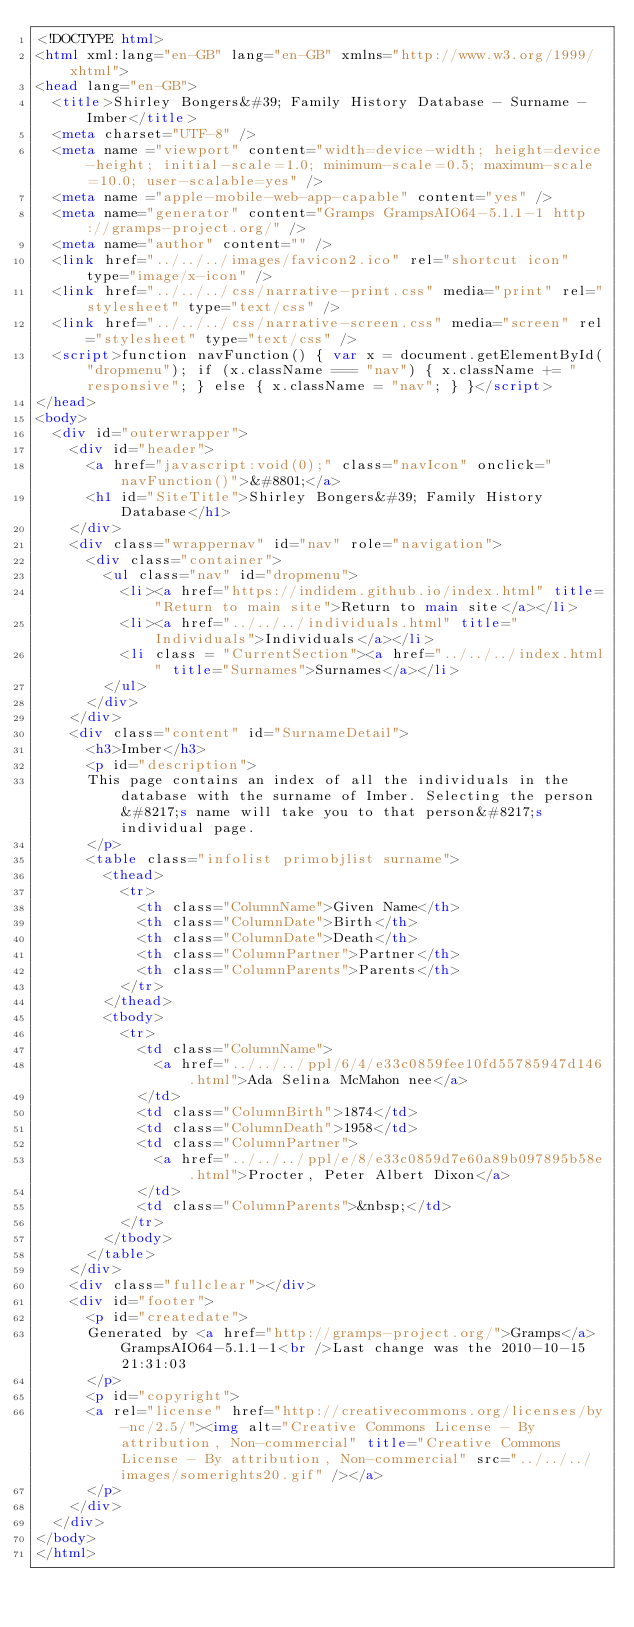Convert code to text. <code><loc_0><loc_0><loc_500><loc_500><_HTML_><!DOCTYPE html>
<html xml:lang="en-GB" lang="en-GB" xmlns="http://www.w3.org/1999/xhtml">
<head lang="en-GB">
	<title>Shirley Bongers&#39; Family History Database - Surname - Imber</title>
	<meta charset="UTF-8" />
	<meta name ="viewport" content="width=device-width; height=device-height; initial-scale=1.0; minimum-scale=0.5; maximum-scale=10.0; user-scalable=yes" />
	<meta name ="apple-mobile-web-app-capable" content="yes" />
	<meta name="generator" content="Gramps GrampsAIO64-5.1.1-1 http://gramps-project.org/" />
	<meta name="author" content="" />
	<link href="../../../images/favicon2.ico" rel="shortcut icon" type="image/x-icon" />
	<link href="../../../css/narrative-print.css" media="print" rel="stylesheet" type="text/css" />
	<link href="../../../css/narrative-screen.css" media="screen" rel="stylesheet" type="text/css" />
	<script>function navFunction() { var x = document.getElementById("dropmenu"); if (x.className === "nav") { x.className += " responsive"; } else { x.className = "nav"; } }</script>
</head>
<body>
	<div id="outerwrapper">
		<div id="header">
			<a href="javascript:void(0);" class="navIcon" onclick="navFunction()">&#8801;</a>
			<h1 id="SiteTitle">Shirley Bongers&#39; Family History Database</h1>
		</div>
		<div class="wrappernav" id="nav" role="navigation">
			<div class="container">
				<ul class="nav" id="dropmenu">
					<li><a href="https://indidem.github.io/index.html" title="Return to main site">Return to main site</a></li>
					<li><a href="../../../individuals.html" title="Individuals">Individuals</a></li>
					<li class = "CurrentSection"><a href="../../../index.html" title="Surnames">Surnames</a></li>
				</ul>
			</div>
		</div>
		<div class="content" id="SurnameDetail">
			<h3>Imber</h3>
			<p id="description">
			This page contains an index of all the individuals in the database with the surname of Imber. Selecting the person&#8217;s name will take you to that person&#8217;s individual page.
			</p>
			<table class="infolist primobjlist surname">
				<thead>
					<tr>
						<th class="ColumnName">Given Name</th>
						<th class="ColumnDate">Birth</th>
						<th class="ColumnDate">Death</th>
						<th class="ColumnPartner">Partner</th>
						<th class="ColumnParents">Parents</th>
					</tr>
				</thead>
				<tbody>
					<tr>
						<td class="ColumnName">
							<a href="../../../ppl/6/4/e33c0859fee10fd55785947d146.html">Ada Selina McMahon nee</a>
						</td>
						<td class="ColumnBirth">1874</td>
						<td class="ColumnDeath">1958</td>
						<td class="ColumnPartner">
							<a href="../../../ppl/e/8/e33c0859d7e60a89b097895b58e.html">Procter, Peter Albert Dixon</a>
						</td>
						<td class="ColumnParents">&nbsp;</td>
					</tr>
				</tbody>
			</table>
		</div>
		<div class="fullclear"></div>
		<div id="footer">
			<p id="createdate">
			Generated by <a href="http://gramps-project.org/">Gramps</a> GrampsAIO64-5.1.1-1<br />Last change was the 2010-10-15 21:31:03
			</p>
			<p id="copyright">
			<a rel="license" href="http://creativecommons.org/licenses/by-nc/2.5/"><img alt="Creative Commons License - By attribution, Non-commercial" title="Creative Commons License - By attribution, Non-commercial" src="../../../images/somerights20.gif" /></a>
			</p>
		</div>
	</div>
</body>
</html>
</code> 